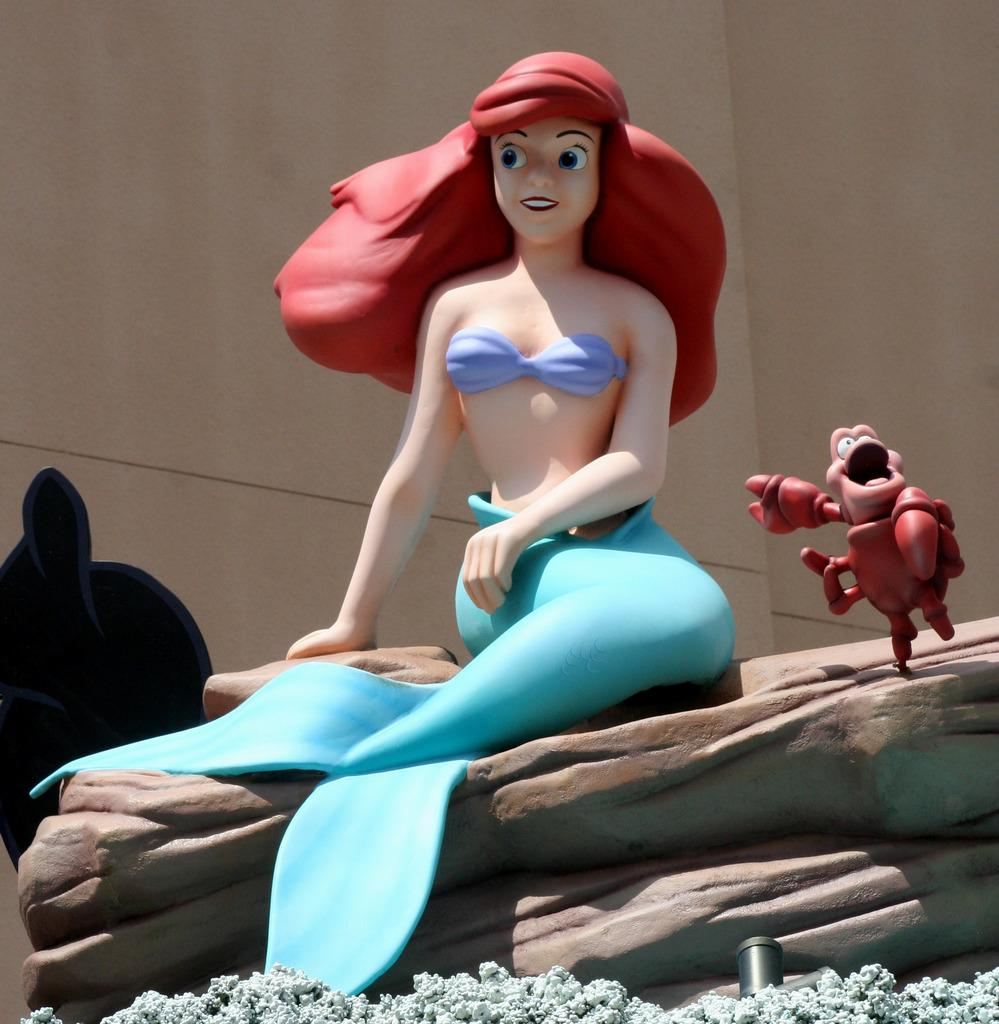What type of objects can be seen in the image? There are toys in the image. Can you describe the toys in more detail? The toys include a woman and a crab on a rock. What else can be seen in the image besides the toys? There is an object visible on the backside of the image and a wall in the image. What is the best route to take to avoid the jam in the image? There is no jam present in the image, as it features toys with a woman and a crab on a rock. 